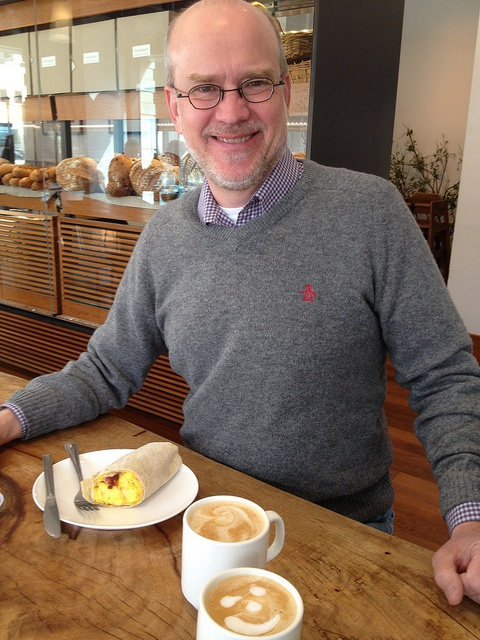Describe the objects in this image and their specific colors. I can see people in gray, black, and brown tones, dining table in gray, brown, ivory, and maroon tones, cup in gray, white, tan, and darkgray tones, cup in gray, tan, and ivory tones, and sandwich in gray, khaki, and tan tones in this image. 